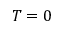<formula> <loc_0><loc_0><loc_500><loc_500>T = 0</formula> 